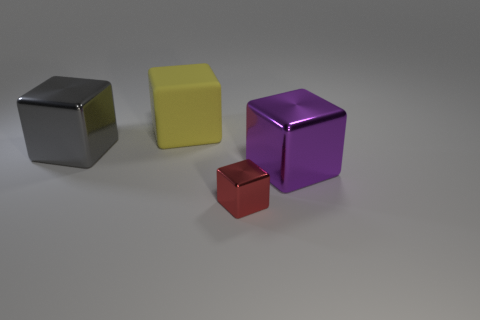Add 4 yellow balls. How many objects exist? 8 Subtract all large red rubber blocks. Subtract all big objects. How many objects are left? 1 Add 1 yellow things. How many yellow things are left? 2 Add 4 big yellow blocks. How many big yellow blocks exist? 5 Subtract 0 blue cubes. How many objects are left? 4 